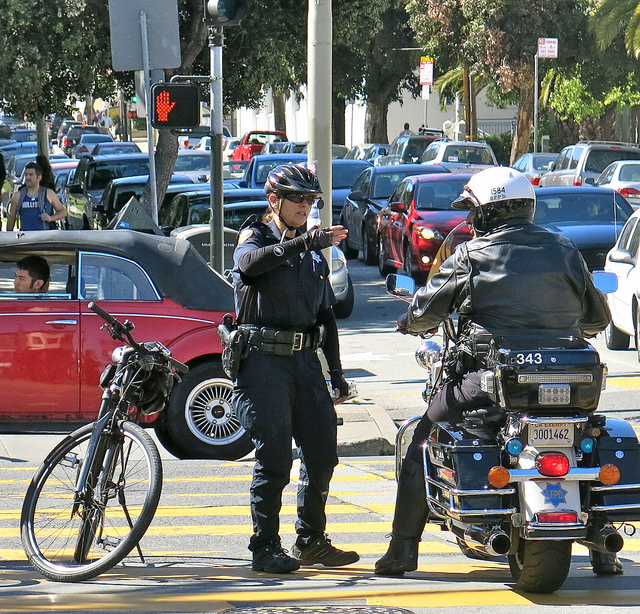What safety equipment can you identify on the police officers? Both officers are wearing protective helmets, which are essential for motorcycle riders. Additionally, they are equipped with utility belts holding various equipment, such as radios for communication, possibly handcuffs and firearms, and other tools necessary for law enforcement. Their uniforms may also have protective padding, and their boots are likely reinforced for safety and durability. 